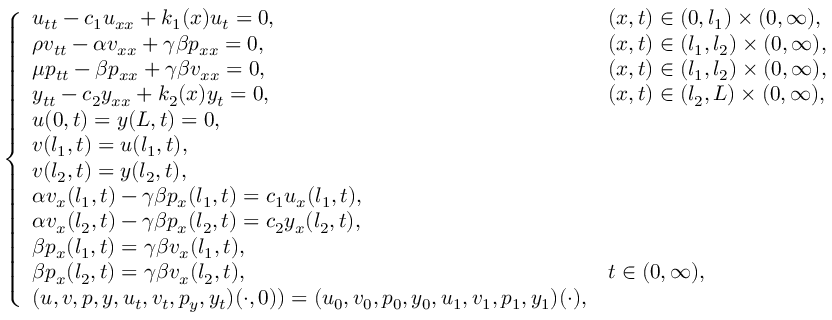<formula> <loc_0><loc_0><loc_500><loc_500>\left \{ \begin{array} { l l } { u _ { t t } - c _ { 1 } u _ { x x } + k _ { 1 } ( x ) u _ { t } = 0 , } & { ( x , t ) \in ( 0 , l _ { 1 } ) \times ( 0 , \infty ) , } \\ { \rho v _ { t t } - \alpha v _ { x x } + \gamma \beta p _ { x x } = 0 , } & { ( x , t ) \in ( l _ { 1 } , l _ { 2 } ) \times ( 0 , \infty ) , } \\ { \mu p _ { t t } - \beta p _ { x x } + \gamma \beta v _ { x x } = 0 , } & { ( x , t ) \in ( l _ { 1 } , l _ { 2 } ) \times ( 0 , \infty ) , } \\ { y _ { t t } - c _ { 2 } y _ { x x } + k _ { 2 } ( x ) y _ { t } = 0 , } & { ( x , t ) \in ( l _ { 2 } , L ) \times ( 0 , \infty ) , } \\ { u ( 0 , t ) = y ( L , t ) = 0 , } \\ { v ( l _ { 1 } , t ) = u ( l _ { 1 } , t ) , } \\ { v ( l _ { 2 } , t ) = y ( l _ { 2 } , t ) , } \\ { \alpha v _ { x } ( l _ { 1 } , t ) - \gamma \beta p _ { x } ( l _ { 1 } , t ) = c _ { 1 } u _ { x } ( l _ { 1 } , t ) , } & \\ { \alpha v _ { x } ( l _ { 2 } , t ) - \gamma \beta p _ { x } ( l _ { 2 } , t ) = c _ { 2 } y _ { x } ( l _ { 2 } , t ) , } & \\ { \beta p _ { x } ( l _ { 1 } , t ) = \gamma \beta v _ { x } ( l _ { 1 } , t ) , } & \\ { \beta p _ { x } ( l _ { 2 } , t ) = \gamma \beta v _ { x } ( l _ { 2 } , t ) , } & { t \in ( 0 , \infty ) , } \\ { ( u , v , p , y , u _ { t } , v _ { t } , p _ { y } , y _ { t } ) ( \cdot , 0 ) ) = ( u _ { 0 } , v _ { 0 } , p _ { 0 } , y _ { 0 } , u _ { 1 } , v _ { 1 } , p _ { 1 } , y _ { 1 } ) ( \cdot ) , } \end{array}</formula> 